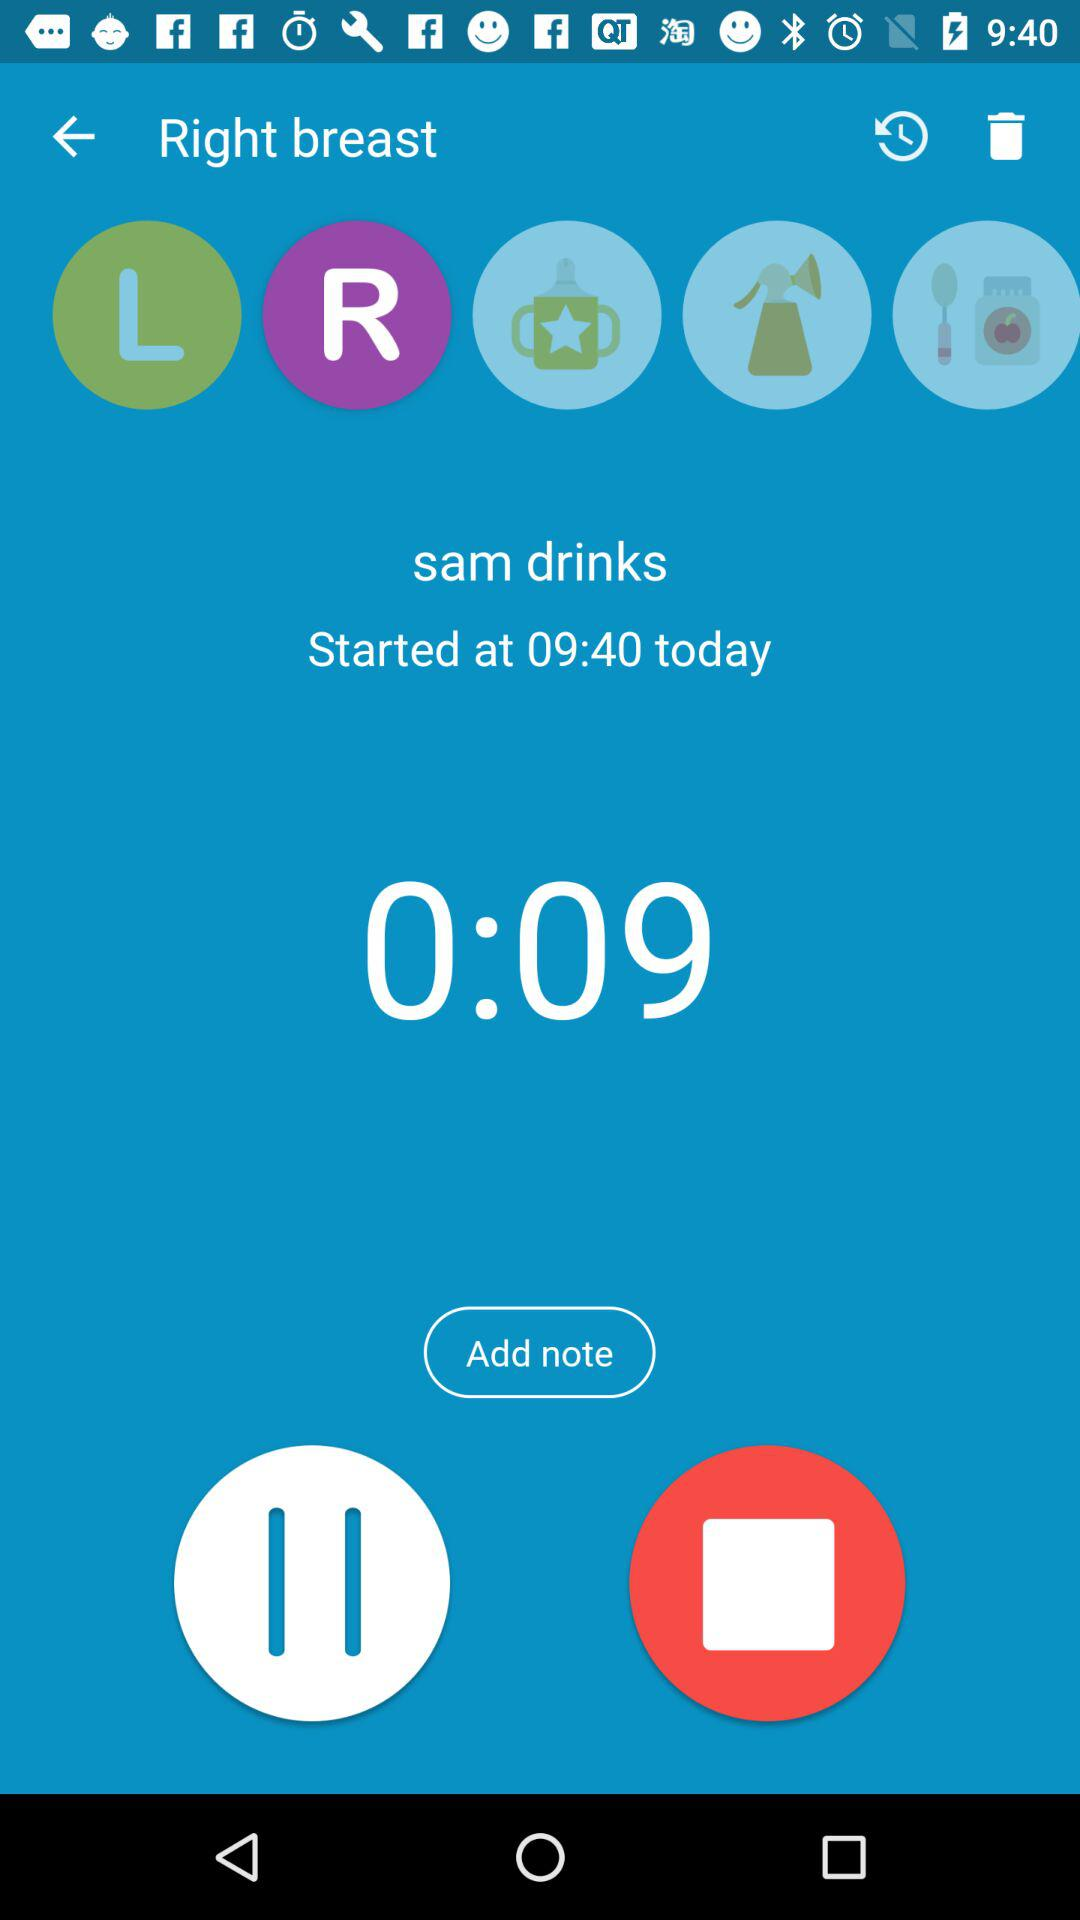What is the displayed time? The displayed time is 0:09. 